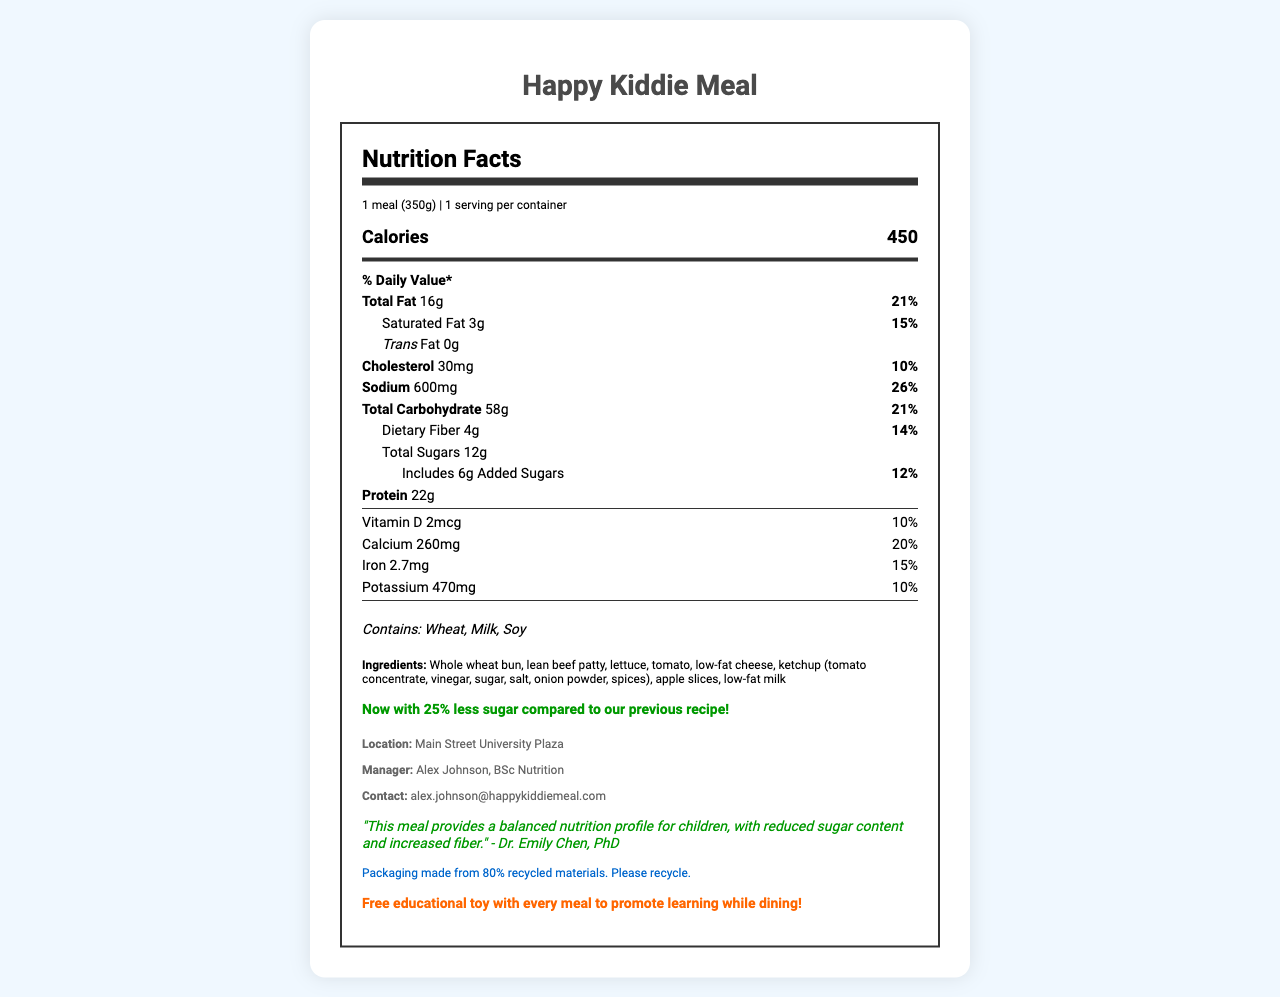What is the serving size of the Happy Kiddie Meal? The serving size is listed as "1 meal (350g)" in the nutrition information.
Answer: 1 meal (350g) How many calories are in one serving of the Happy Kiddie Meal? The document indicates that one serving of the Happy Kiddie Meal contains 450 calories.
Answer: 450 What is the total fat content in one serving and its daily value percentage? The nutrition label states that the total fat content is 16g, which corresponds to 21% of the daily value.
Answer: 16g, 21% How much added sugar is in the Happy Kiddie Meal? The document shows that there are 6g of added sugars, which account for 12% of the daily value.
Answer: 6g, 12% Which allergens are present in the Happy Kiddie Meal? The allergens listed are Wheat, Milk, and Soy.
Answer: Wheat, Milk, Soy Which of the following is NOT an ingredient in the Happy Kiddie Meal?  
A. Lean beef patty  
B. Chicken breast  
C. Apple slices The ingredient list includes lean beef patty and apple slices, but does not mention chicken breast.
Answer: B. Chicken breast What is the daily value percentage for sodium in one serving?  
A. 10%  
B. 14%  
C. 26%  
D. 30% The sodium content has a daily value percentage of 26% as listed in the nutrition facts.
Answer: C. 26% Does the Happy Kiddie Meal contain trans fat? The label clearly states that the Trans Fat content is 0g.
Answer: No Is the Happy Kiddie Meal manager a certified nutritionist? The manager, Alex Johnson, has a BSc in Nutrition, as stated in the franchise-specific info.
Answer: Yes Summarize the main nutritional and promotional highlights of the Happy Kiddie Meal. The document summarizes the key nutritional values, highlights the reduced sugar content and its approval by a nutritionist, promotes sustainability with recycled packaging, and includes a promotional offer of an educational toy.
Answer: The Happy Kiddie Meal contains important nutritional information, including 450 calories, 16g of total fat (21% DV), and 6g of added sugars (12% DV). It includes allergens like Wheat, Milk, and Soy. The meal boasts 25% less sugar compared to a previous recipe and is approved by Dr. Emily Chen, PhD, for its balanced nutrition. Additionally, the packaging is made from 80% recycled materials, and each meal comes with a free educational toy. What is the exact ingredient list for the Happy Kiddie Meal? The document does not provide the exact quantities for each ingredient.
Answer: Cannot be determined Who approved the nutrition profile of the Happy Kiddie Meal? Dr. Emily Chen, PhD, approved the nutrition profile as stated in the document.
Answer: Dr. Emily Chen, PhD 